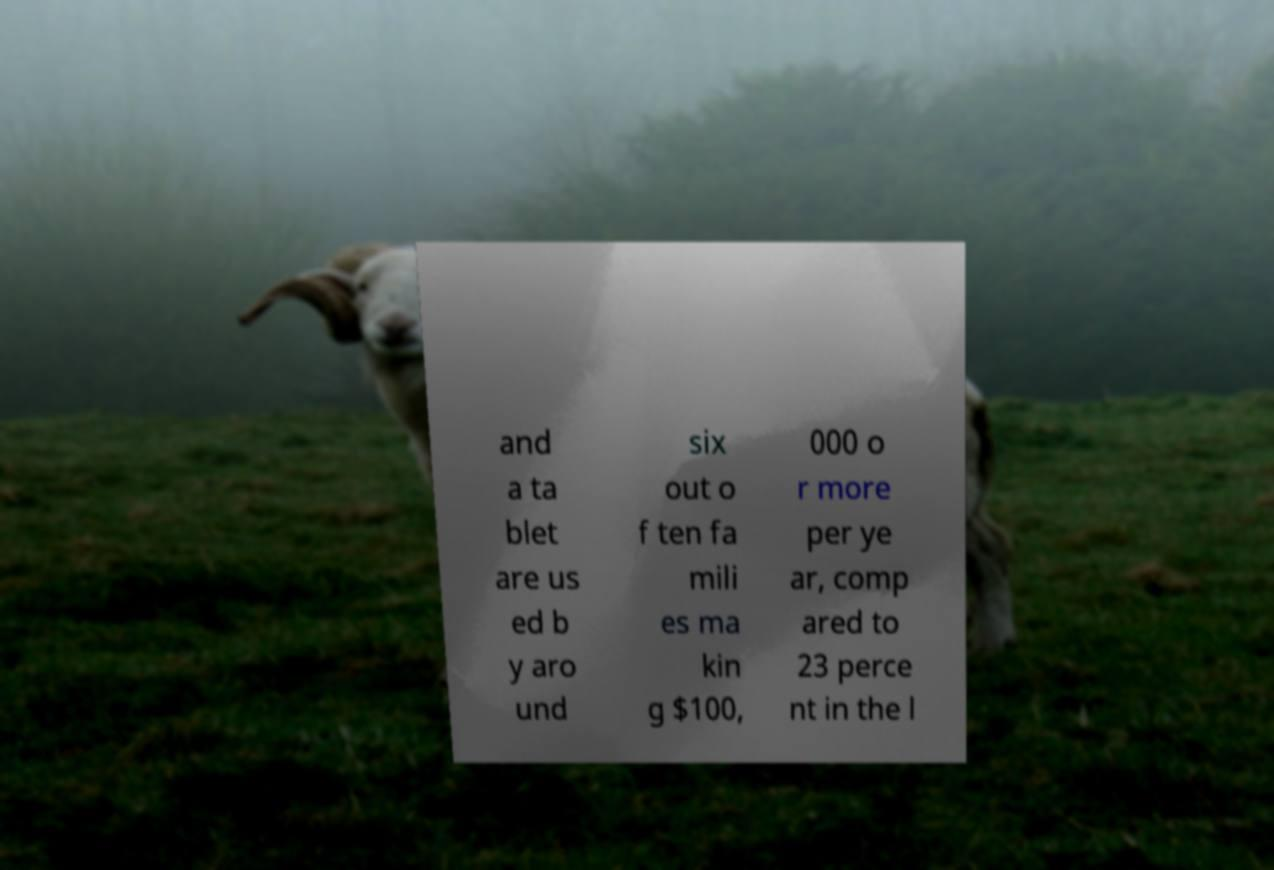Can you accurately transcribe the text from the provided image for me? and a ta blet are us ed b y aro und six out o f ten fa mili es ma kin g $100, 000 o r more per ye ar, comp ared to 23 perce nt in the l 